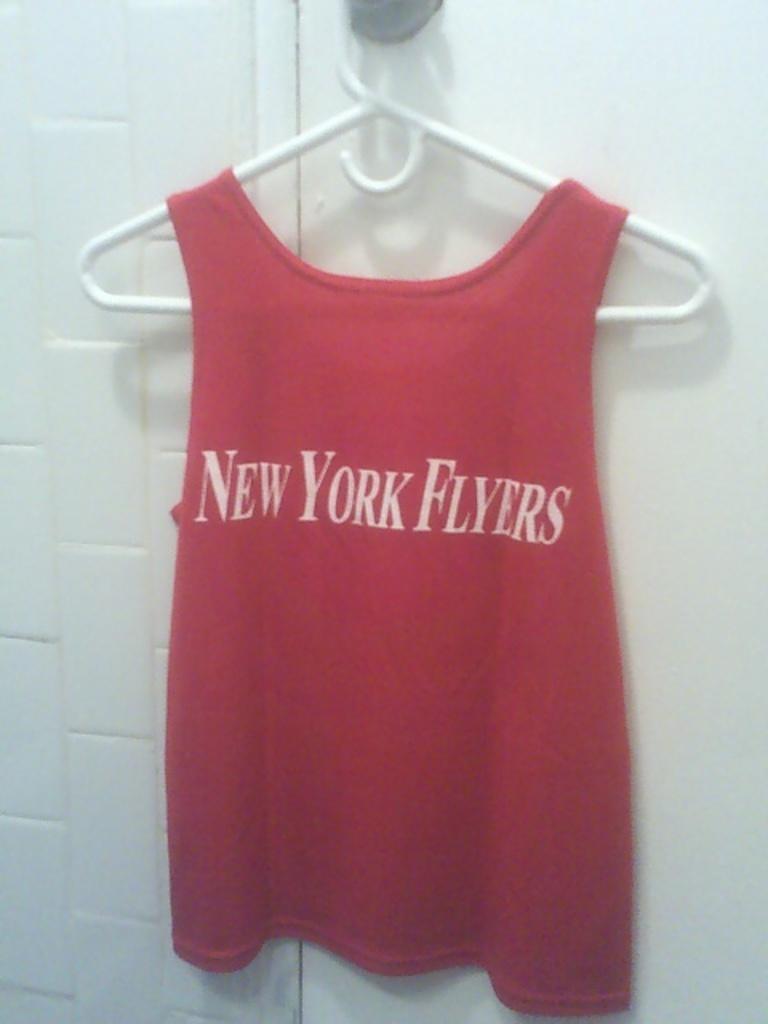In one or two sentences, can you explain what this image depicts? In this image I can see the red color dress to the hanger. On the dress I can see the name new York flyers is written. In the background I can see the white wall. 